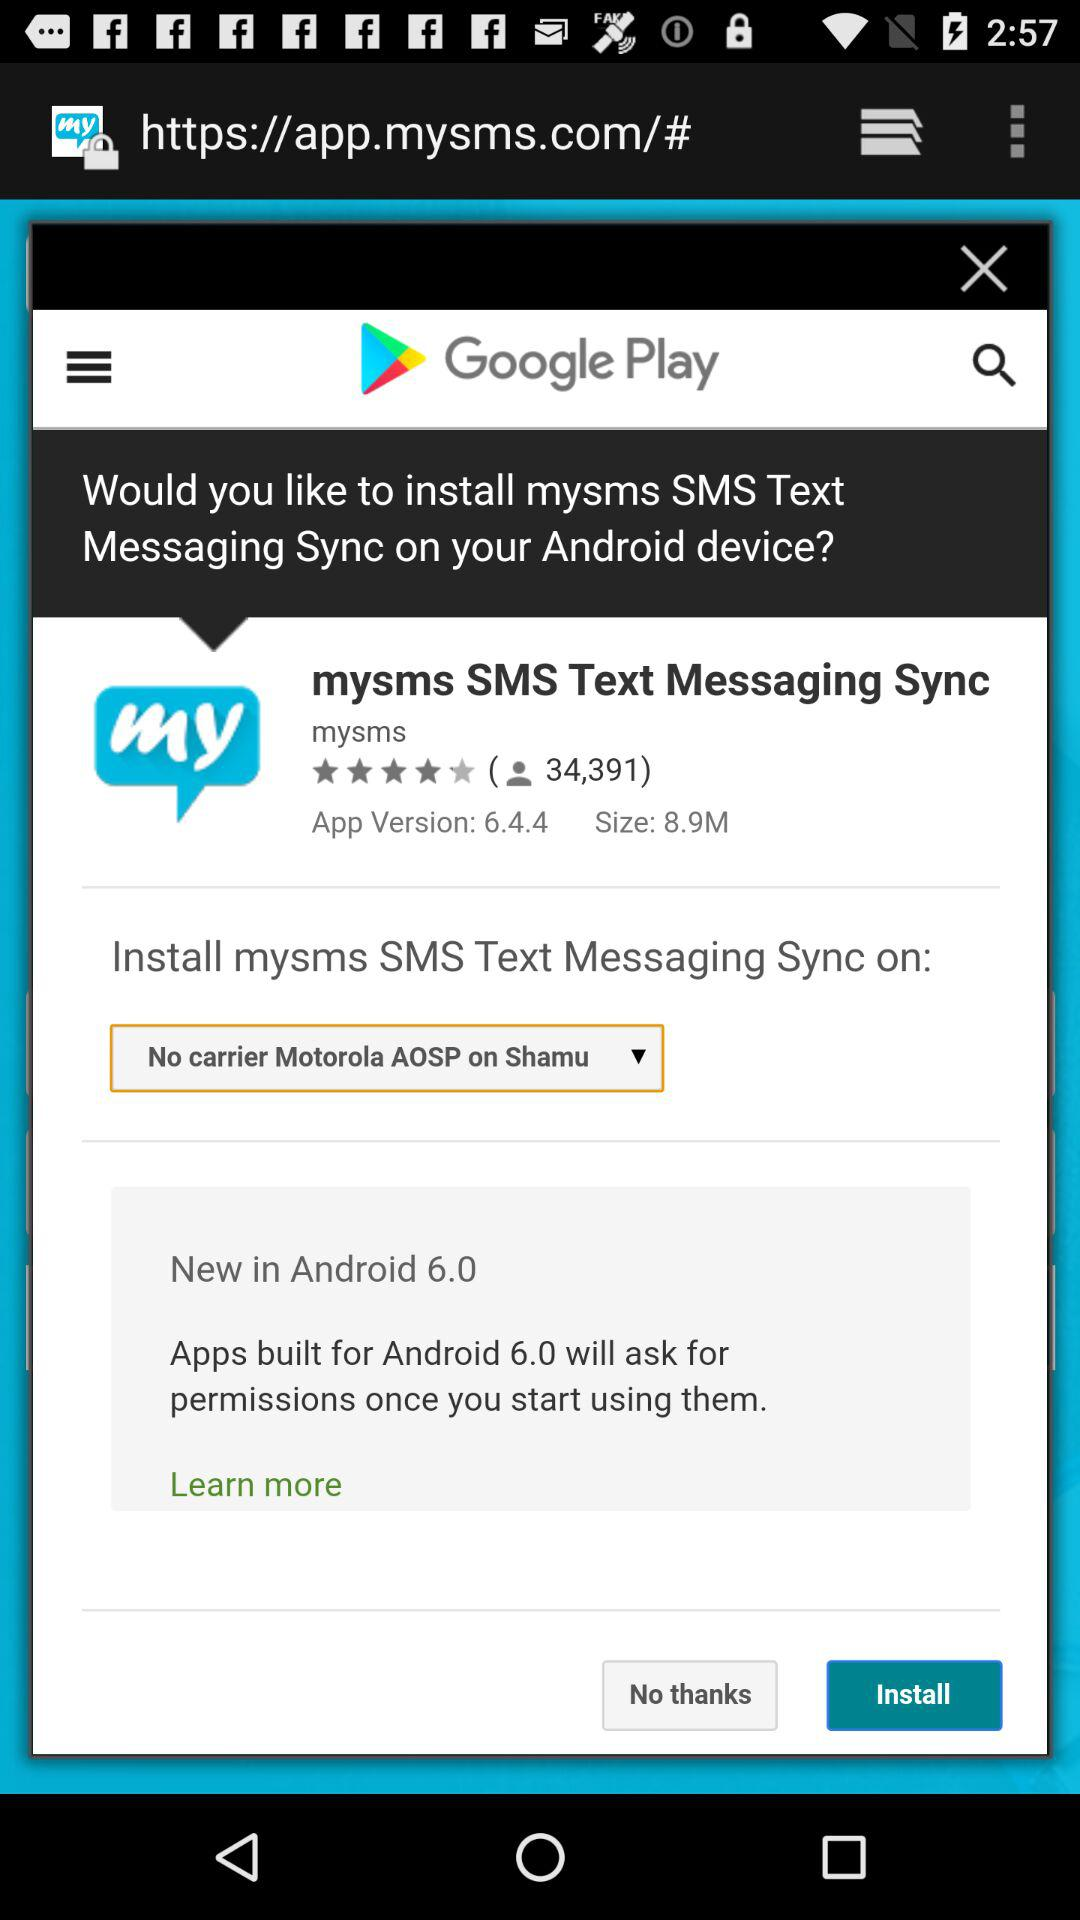Which application asking for permission to install?
When the provided information is insufficient, respond with <no answer>. <no answer> 